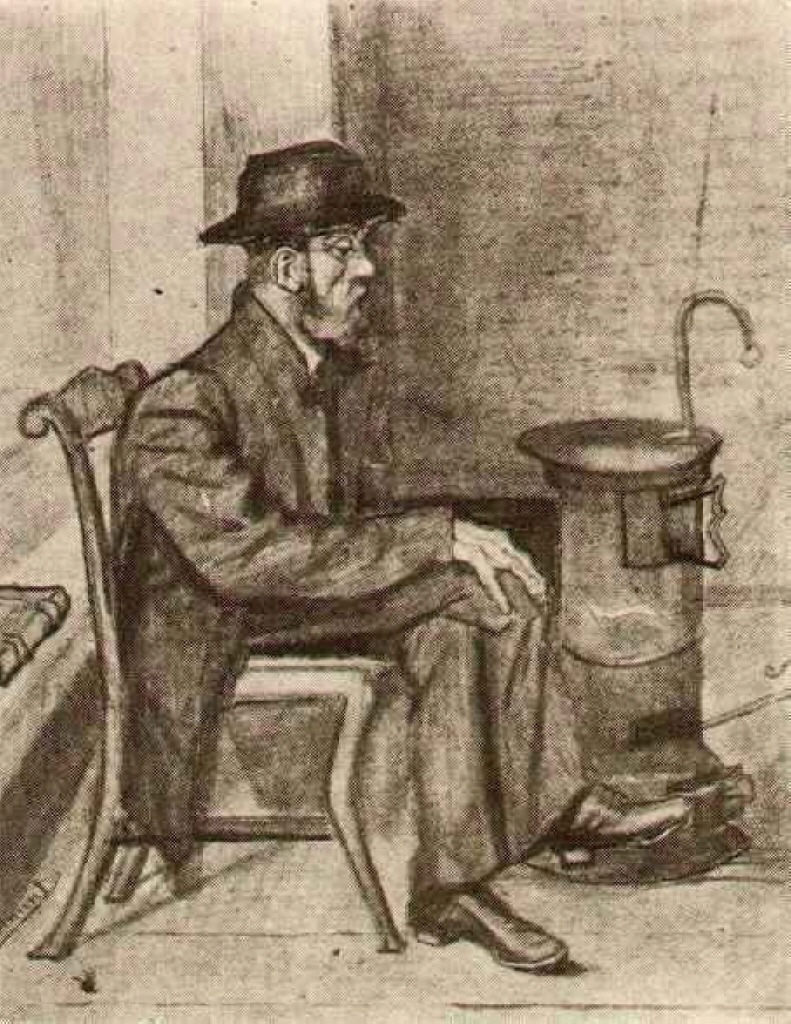What are the key elements in this picture? The image depicts a scene showing a man deeply immersed in his thoughts, seated on a sturdy chair beside an old-fashioned stove. The man is clad in a dark hat and coat, which implies a colder environment. The focus on the man's face and the stove suggests the significance of these elements in the composition. The artwork employs a loose and sketchy drawing technique, which imbues it with a sense of dynamism and life. The palette consists of muted colors, reinforcing the realistic nature of the piece. This portrayal fits within the genre of realist portraiture, capturing the somber mood and intimate setting of the man’s environment. 